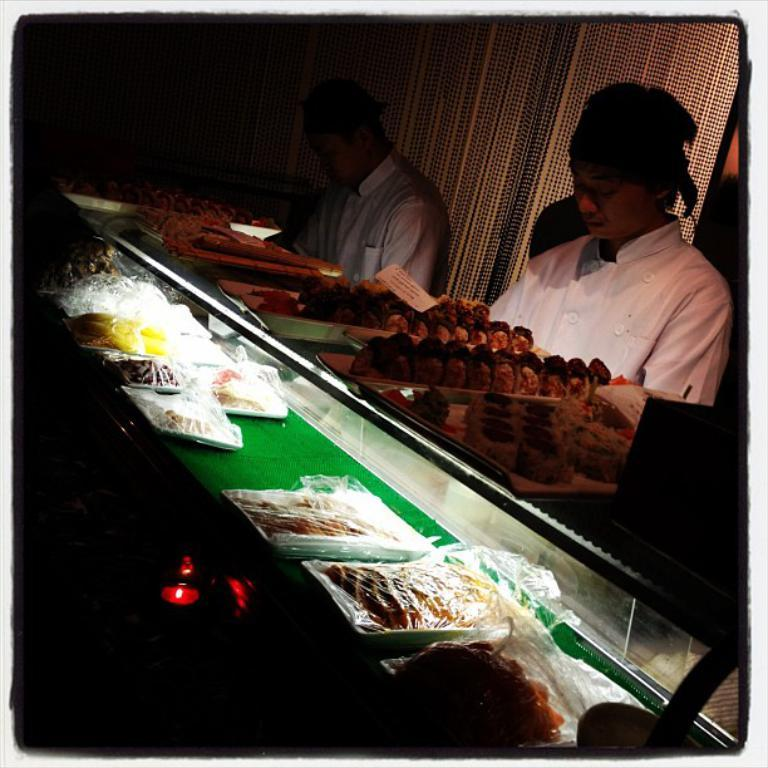How many people are in the image? There are two persons in the image. What is the person on the right wearing? The person on the right is wearing a white shirt. What can be seen on the glass surface in the image? There are food items visible on a glass surface. What type of amusement park can be seen in the background of the image? There is no amusement park visible in the image; it only features two persons and food items on a glass surface. Are there any lawyers present in the image? There is no indication of any lawyers being present in the image. 